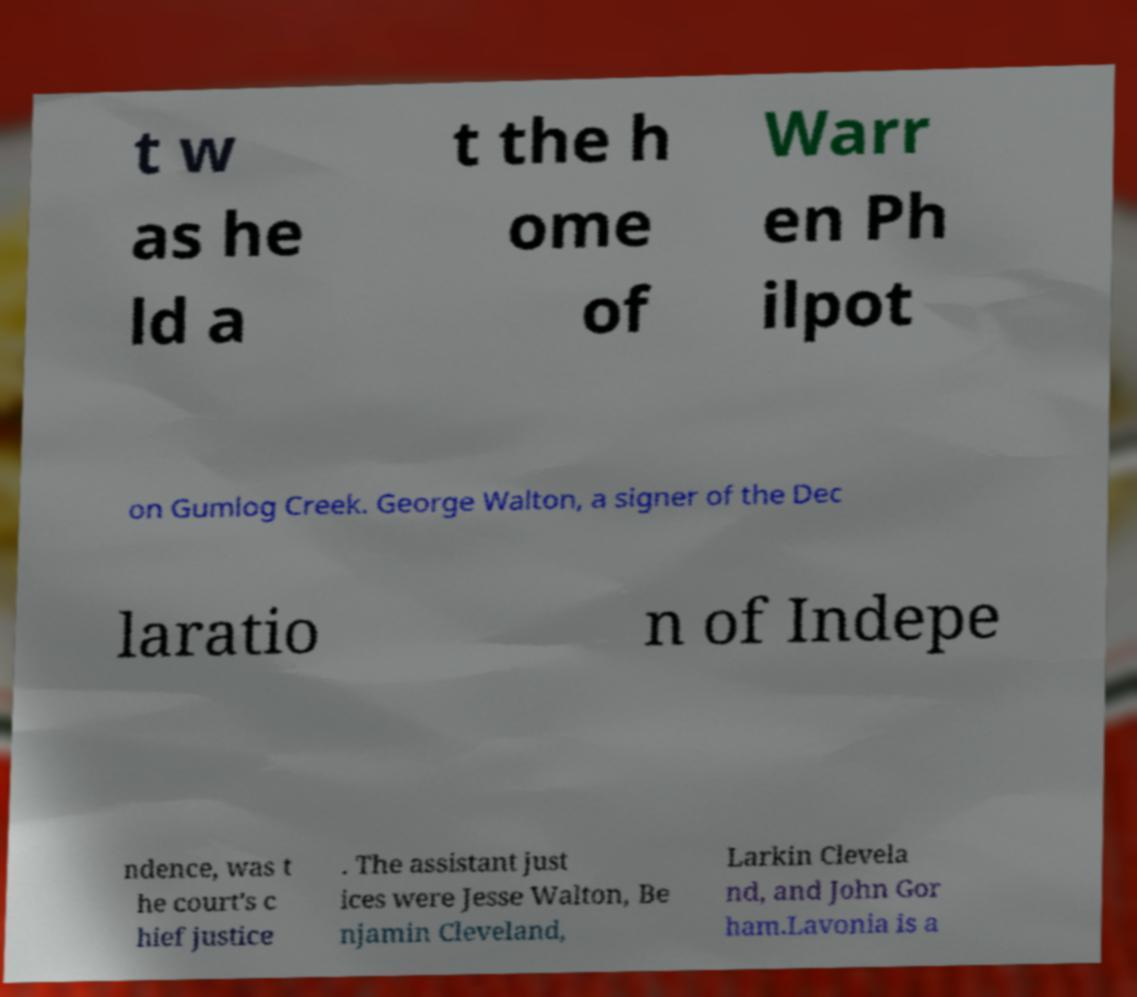Please read and relay the text visible in this image. What does it say? t w as he ld a t the h ome of Warr en Ph ilpot on Gumlog Creek. George Walton, a signer of the Dec laratio n of Indepe ndence, was t he court's c hief justice . The assistant just ices were Jesse Walton, Be njamin Cleveland, Larkin Clevela nd, and John Gor ham.Lavonia is a 